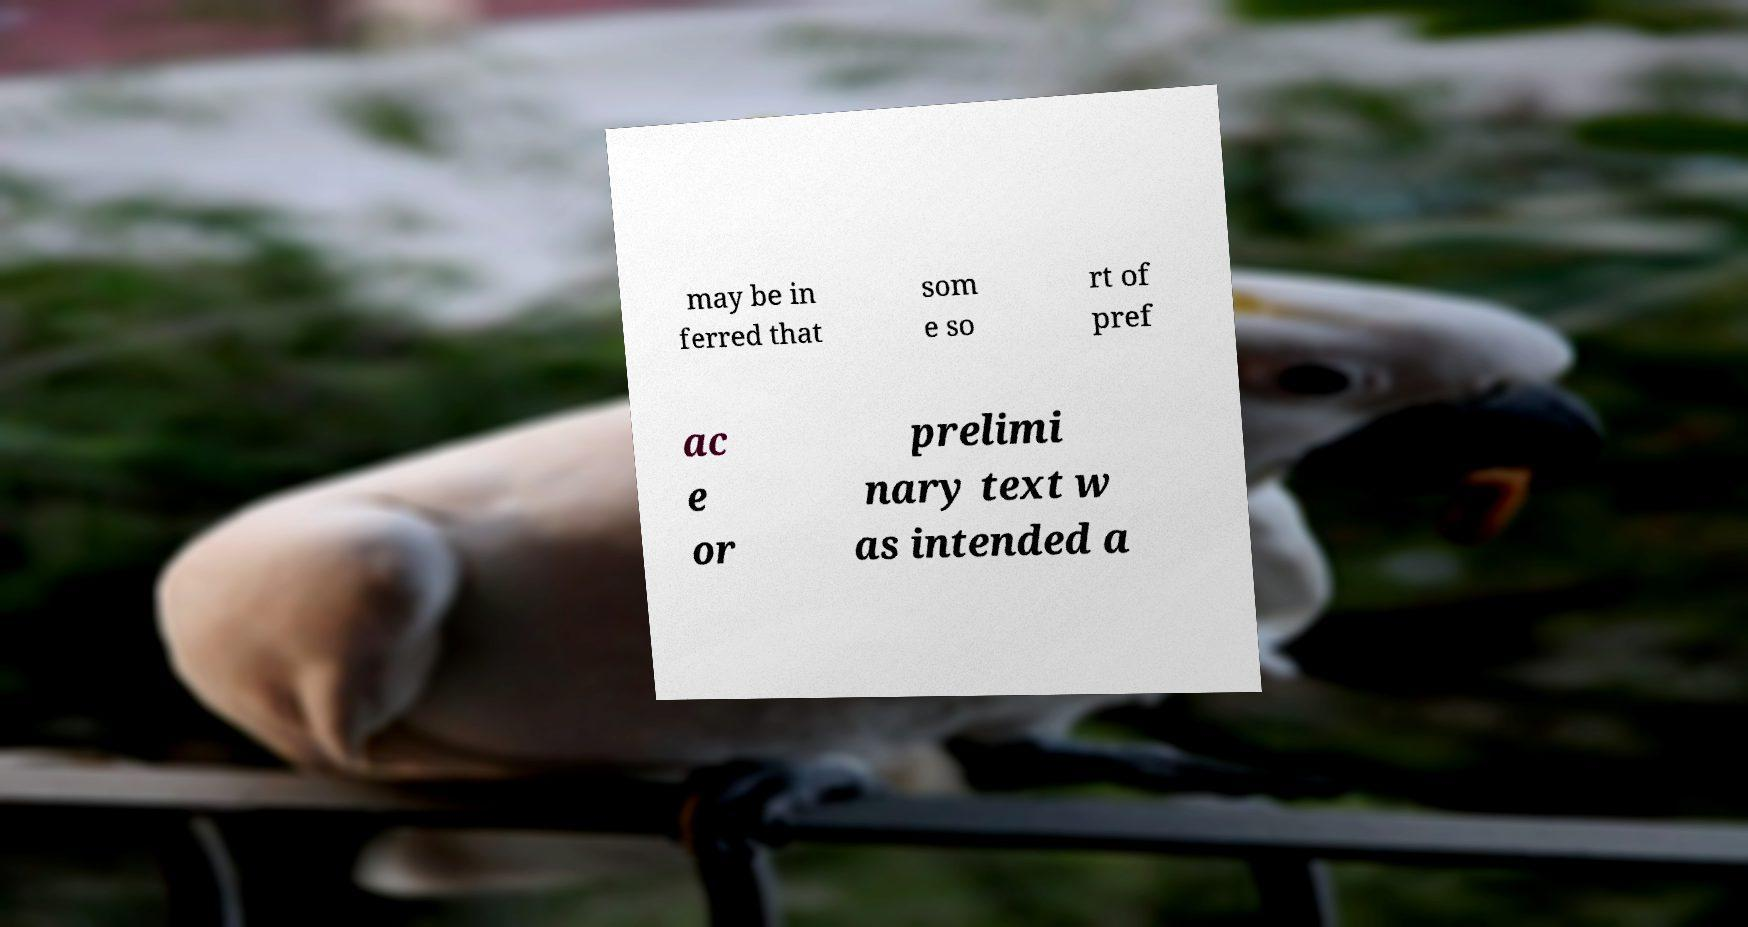There's text embedded in this image that I need extracted. Can you transcribe it verbatim? may be in ferred that som e so rt of pref ac e or prelimi nary text w as intended a 